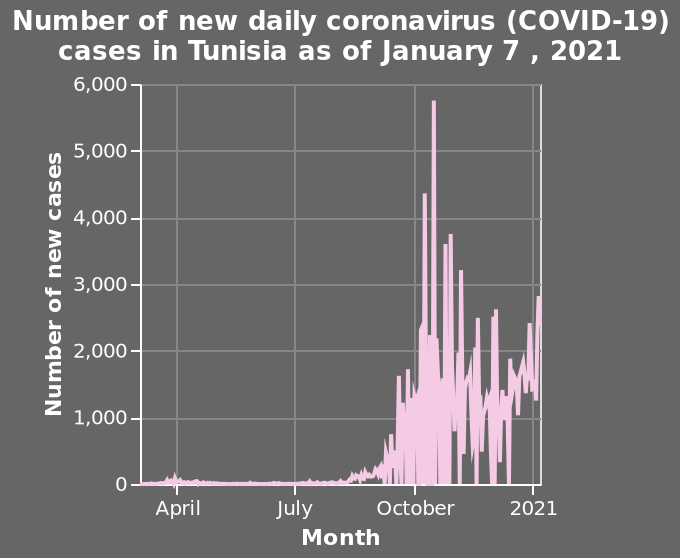<image>
please summary the statistics and relations of the chart the number of cases was low and steady, until september 2020, at which point there was a large spike in cases which peaked in mid october. there was then a decline in cases. When did the large spike in cases occur?  The large spike in cases occurred in September 2020. What does the x-axis represent in the line diagram?  The x-axis represents the months as a categorical scale starting from April and ending with 2021. Does the x-axis represent the months as a numerical scale starting from April and ending with 2021? No. The x-axis represents the months as a categorical scale starting from April and ending with 2021. 